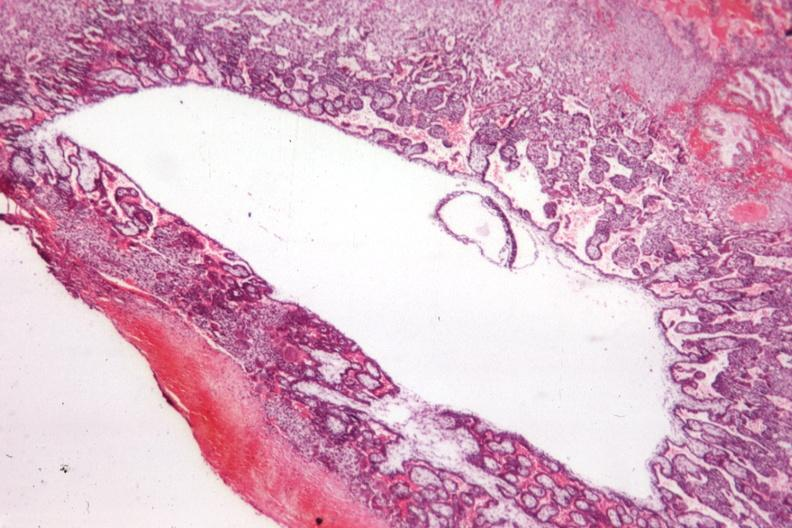s uterus present?
Answer the question using a single word or phrase. Yes 